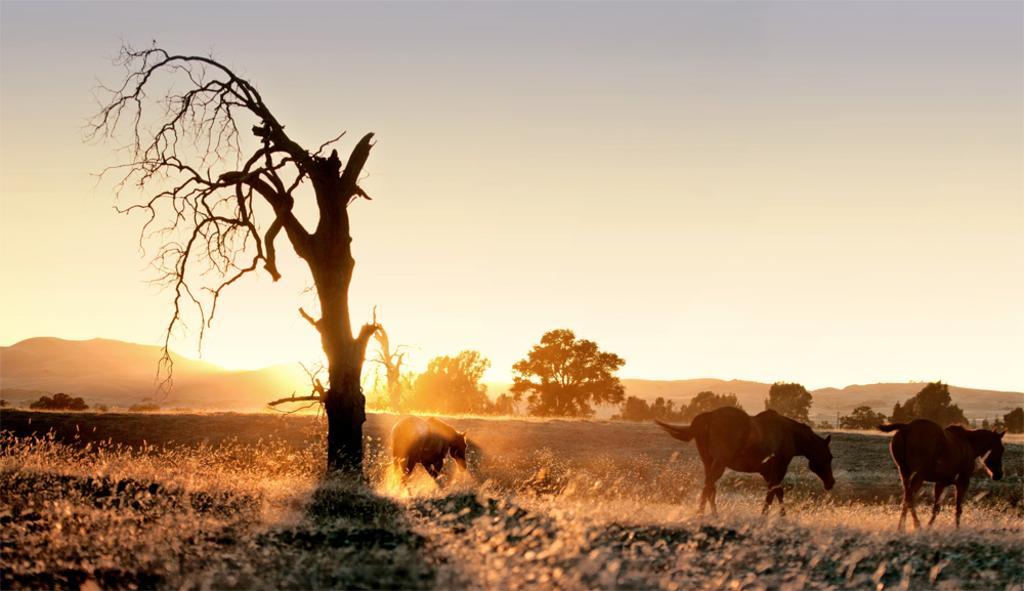In one or two sentences, can you explain what this image depicts? In this image I can see a tree and horses. There are trees and mountains at the back. There is sky at the top. 